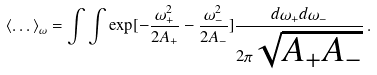Convert formula to latex. <formula><loc_0><loc_0><loc_500><loc_500>\langle \dots \rangle _ { \omega } = \int \int \exp [ - \frac { \omega _ { + } ^ { 2 } } { 2 A _ { + } } - \frac { \omega _ { - } ^ { 2 } } { 2 A _ { - } } ] \frac { d \omega _ { + } d \omega _ { - } } { 2 \pi \sqrt { A _ { + } A _ { - } } } \, .</formula> 